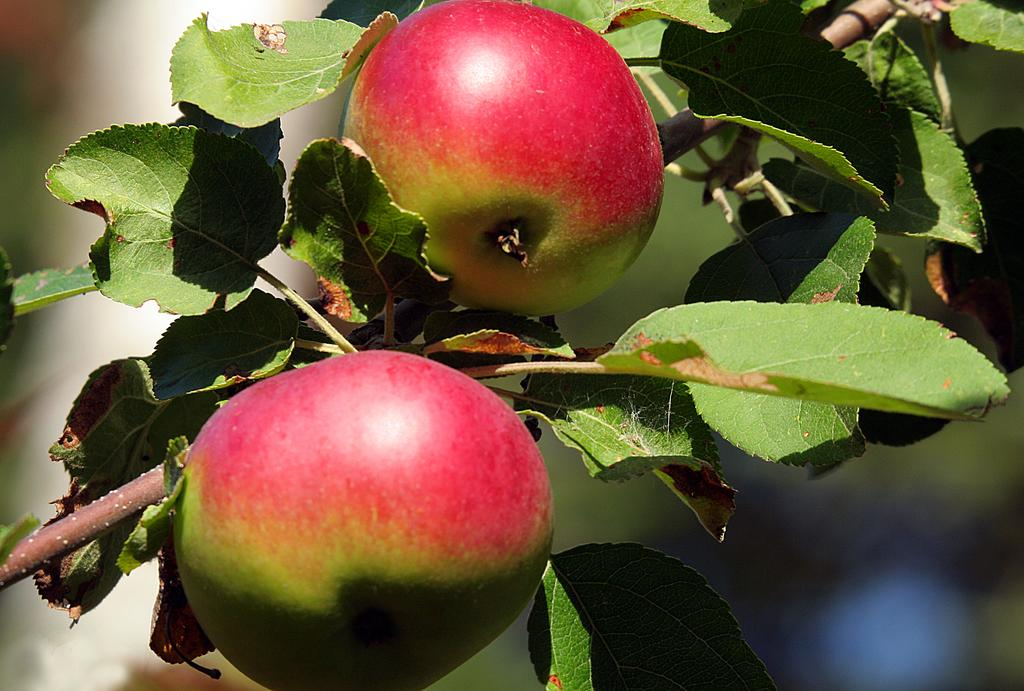How many fruits can be seen in the image? There are two fruits in the image. What is the fruits attached to in the image? The branch of a tree is visible in the image. Can you describe the background of the image? The background of the image is blurred. What type of celery can be seen in the crowd in the image? There is no celery or crowd present in the image; it features two fruits on a tree branch with a blurred background. 